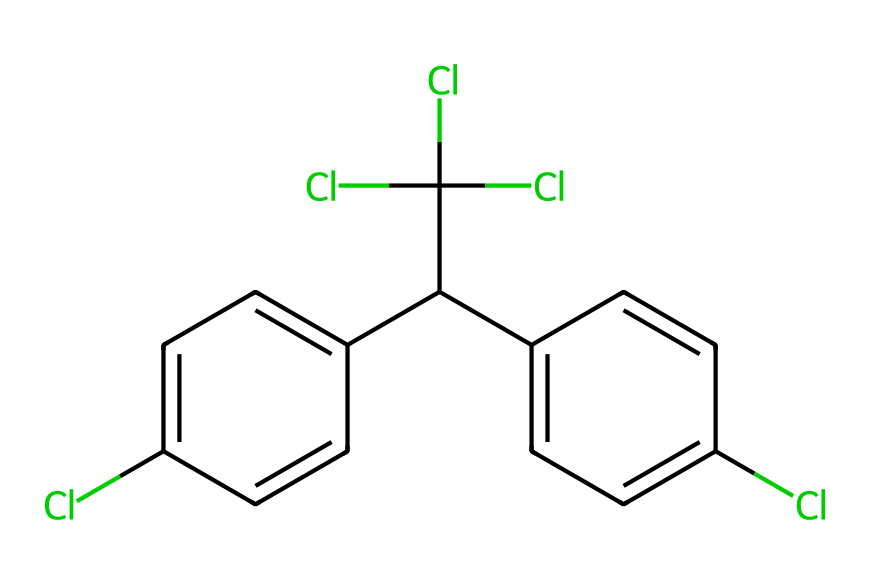What is the name of this chemical? The chemical structure corresponds to Dichloro-Diphenyl-Trichloroethane (DDT), a well-known pesticide.
Answer: DDT How many chlorine (Cl) atoms are present in the structure? By examining the SMILES representation and identifying the Cl symbols, we can count that there are four chlorine atoms in the structure.
Answer: 4 What type of bonds are primarily present in this chemical structure? The structure shows a series of carbon-carbon (C-C) and carbon-chlorine (C-Cl) bonds, indicating that it primarily consists of single and double covalent bonds among these atoms.
Answer: covalent bonds How many benzene rings are present in the structure of DDT? The structure can be identified by looking at the cyclic portions, revealing that there are two distinct benzene rings present in the entire molecule.
Answer: 2 What characteristic of DDT contributes to its accumulation in the environment? The overall chemical structure, which includes multiple chlorine atoms, indicates high lipophilicity, leading to its persistent accumulation in fatty tissues of organisms and the environment.
Answer: lipophilicity What is the significance of the chlorinated structure in DDT's functionality as a pesticide? The presence of chlorine atoms in the structure is crucial as they enhance the molecule's stability and toxicity, making DDT effective against pests.
Answer: stability and toxicity 